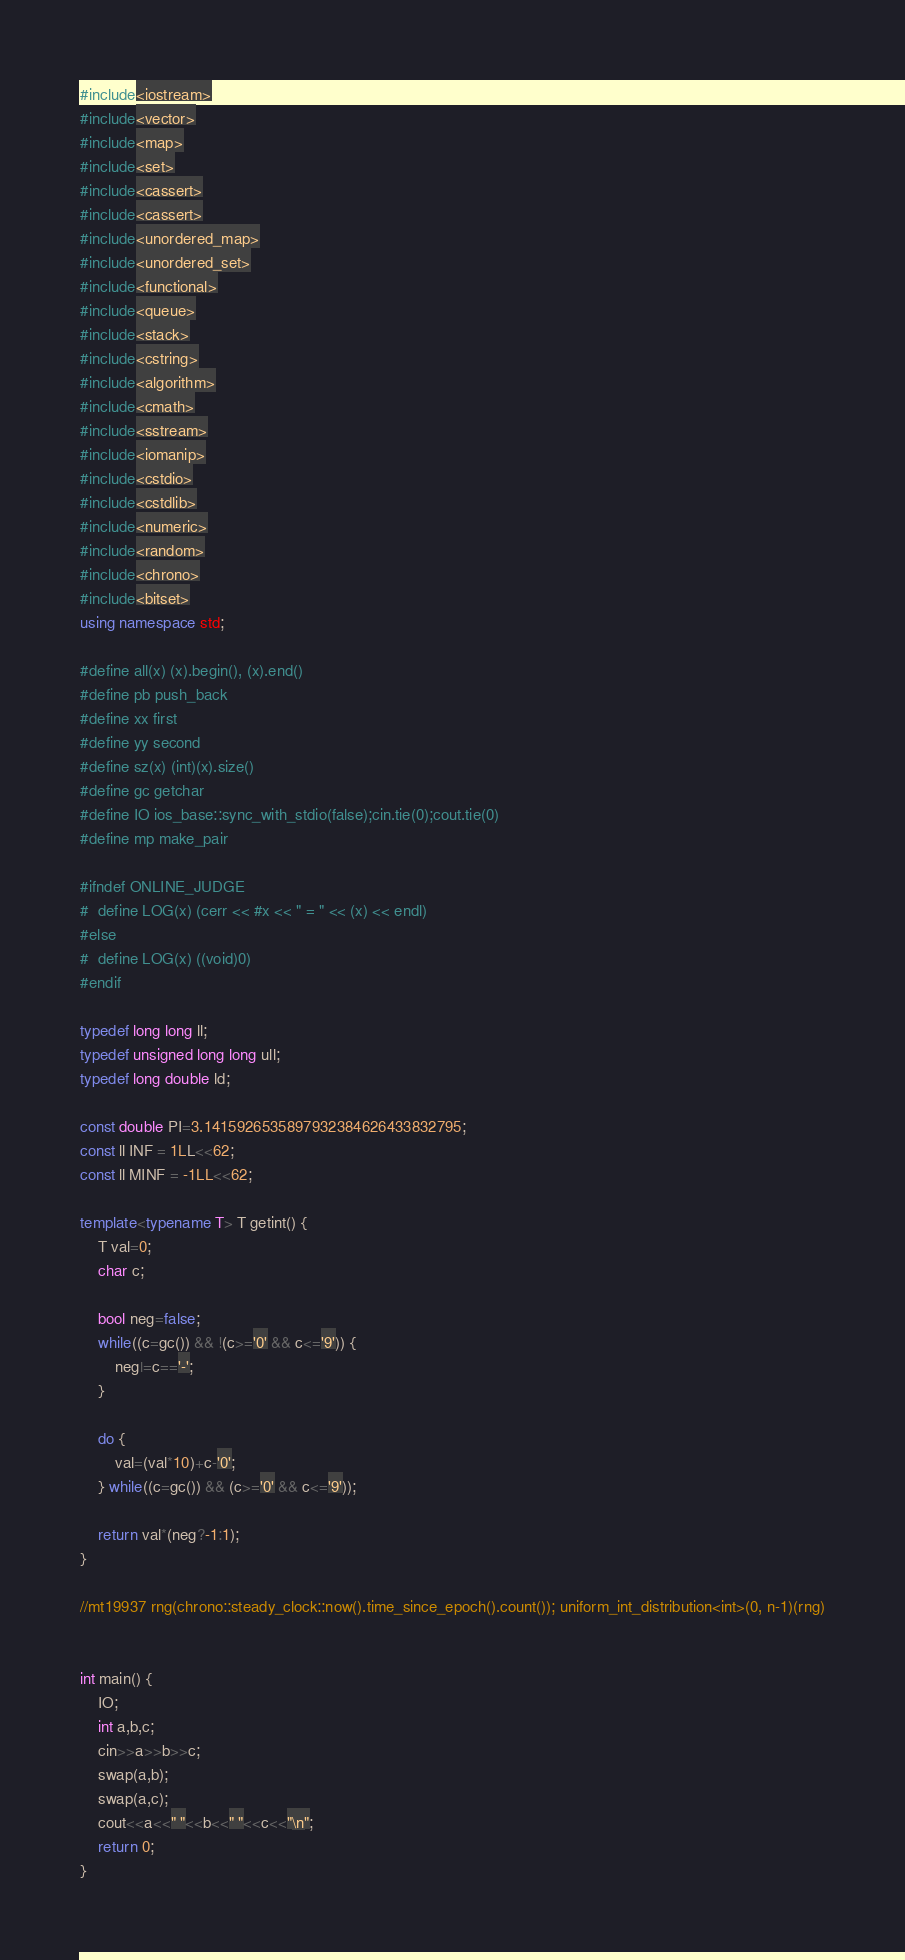<code> <loc_0><loc_0><loc_500><loc_500><_C++_>#include<iostream>
#include<vector>
#include<map>
#include<set>
#include<cassert>
#include<cassert>
#include<unordered_map>
#include<unordered_set>
#include<functional>
#include<queue>
#include<stack>
#include<cstring>
#include<algorithm>
#include<cmath>
#include<sstream>
#include<iomanip>
#include<cstdio>
#include<cstdlib>
#include<numeric>
#include<random>
#include<chrono>
#include<bitset>
using namespace std;

#define all(x) (x).begin(), (x).end()
#define pb push_back
#define xx first
#define yy second
#define sz(x) (int)(x).size()
#define gc getchar
#define IO ios_base::sync_with_stdio(false);cin.tie(0);cout.tie(0)
#define mp make_pair

#ifndef ONLINE_JUDGE
#  define LOG(x) (cerr << #x << " = " << (x) << endl)
#else
#  define LOG(x) ((void)0)
#endif

typedef long long ll;
typedef unsigned long long ull;
typedef long double ld;

const double PI=3.1415926535897932384626433832795;
const ll INF = 1LL<<62;
const ll MINF = -1LL<<62;

template<typename T> T getint() {
	T val=0;
	char c;
	
	bool neg=false;
	while((c=gc()) && !(c>='0' && c<='9')) {
		neg|=c=='-';
	}

	do {
		val=(val*10)+c-'0';
	} while((c=gc()) && (c>='0' && c<='9'));

	return val*(neg?-1:1);
}

//mt19937 rng(chrono::steady_clock::now().time_since_epoch().count()); uniform_int_distribution<int>(0, n-1)(rng)


int main() {
	IO;
	int a,b,c;
	cin>>a>>b>>c;
	swap(a,b);
	swap(a,c);
	cout<<a<<" "<<b<<" "<<c<<"\n";
	return 0;
}
</code> 